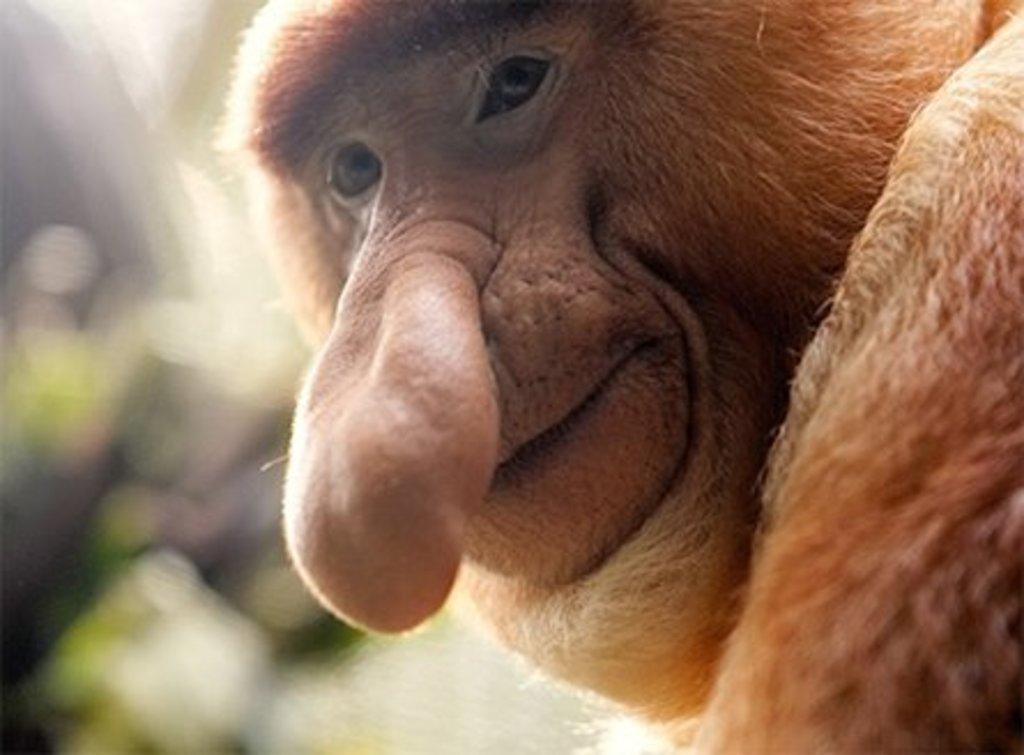What animal is present in the image? There is a monkey in the image. Can you describe the background of the image? The background of the image is blurred. What type of curtain can be seen hanging in the image? There is no curtain present in the image; it features a monkey and a blurred background. What kind of pear is visible in the image? There is no pear present in the image. 